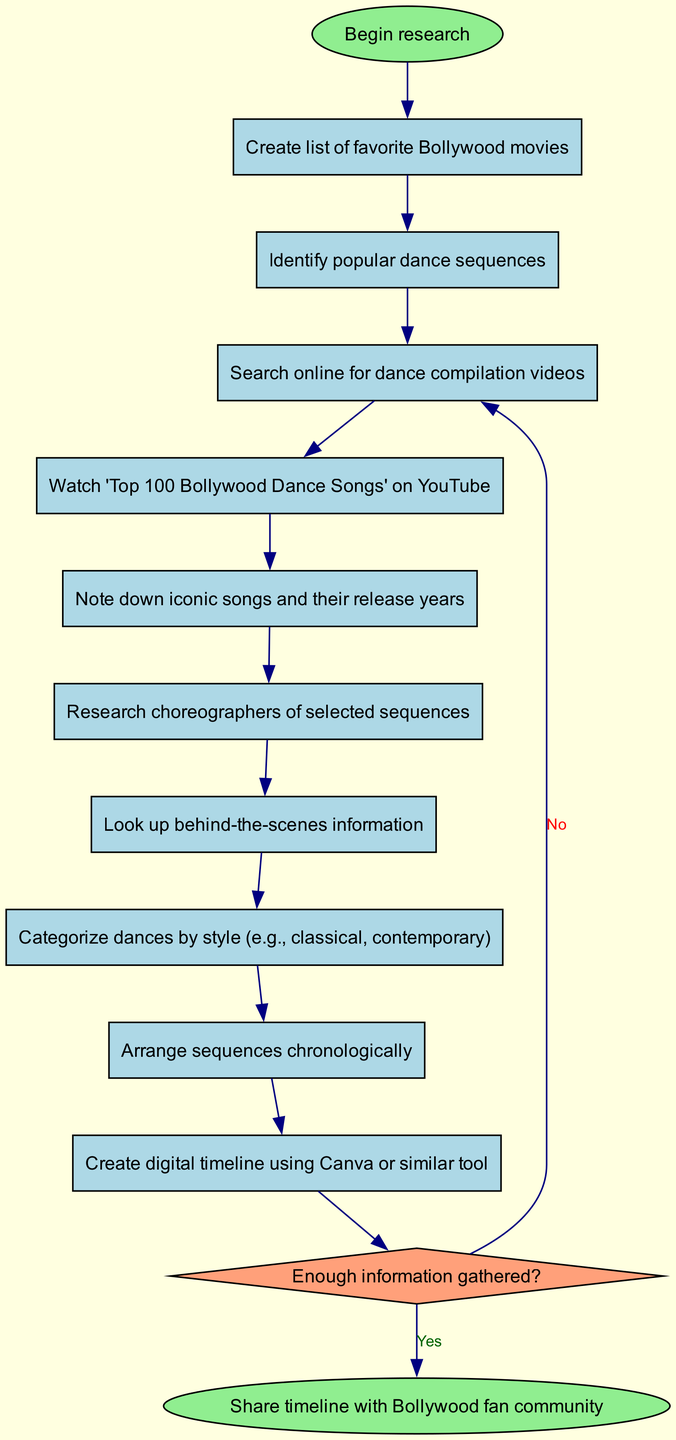What is the starting point of the research? The starting point of the research is represented by the "Begin research" node at the top of the diagram, which indicates the initiation of the entire activity process.
Answer: Begin research How many activities are listed in the diagram? There are ten activities shown in the diagram, starting from creating a list of movies and ending with creating a digital timeline. Each activity is represented as a rectangle node connected sequentially.
Answer: 10 What is the first activity in the sequence? The first activity in the sequence is depicted in the first rectangle node connected to the start node; it is "Create list of favorite Bollywood movies," which kicks off the research process.
Answer: Create list of favorite Bollywood movies What are the two possible outcomes of the decision node? The two outcomes of the decision node indicate whether enough information has been gathered: "Yes" leads to creating a digital timeline, while "No" loops back to continue researching.
Answer: Yes, No Which activity does the "No" decision lead to? The "No" decision from the decision node leads back to the activity "Search online for dance compilation videos," indicating the need to gather more information before proceeding.
Answer: Search online for dance compilation videos How is the final node represented in the diagram? The final node represents the end of the process and is labeled "Share timeline with Bollywood fan community"; it is an oval shape indicating that the activity sequence has been completed successfully.
Answer: Share timeline with Bollywood fan community What is the last activity before reaching the decision node? The last activity before reaching the decision node is "Note down iconic songs and their release years," which occurs just prior to evaluating whether enough information has been gathered.
Answer: Note down iconic songs and their release years What type of diagram is being represented? The diagram represents an Activity Diagram, which illustrates the various steps involved in researching and creating a timeline of Bollywood dance sequences.
Answer: Activity Diagram How are the activities categorized in the diagram? The activities are categorized chronologically, showing the flow from starting research to completing the final timeline, with specific tasks laid out in an orderly fashion.
Answer: Chronologically 